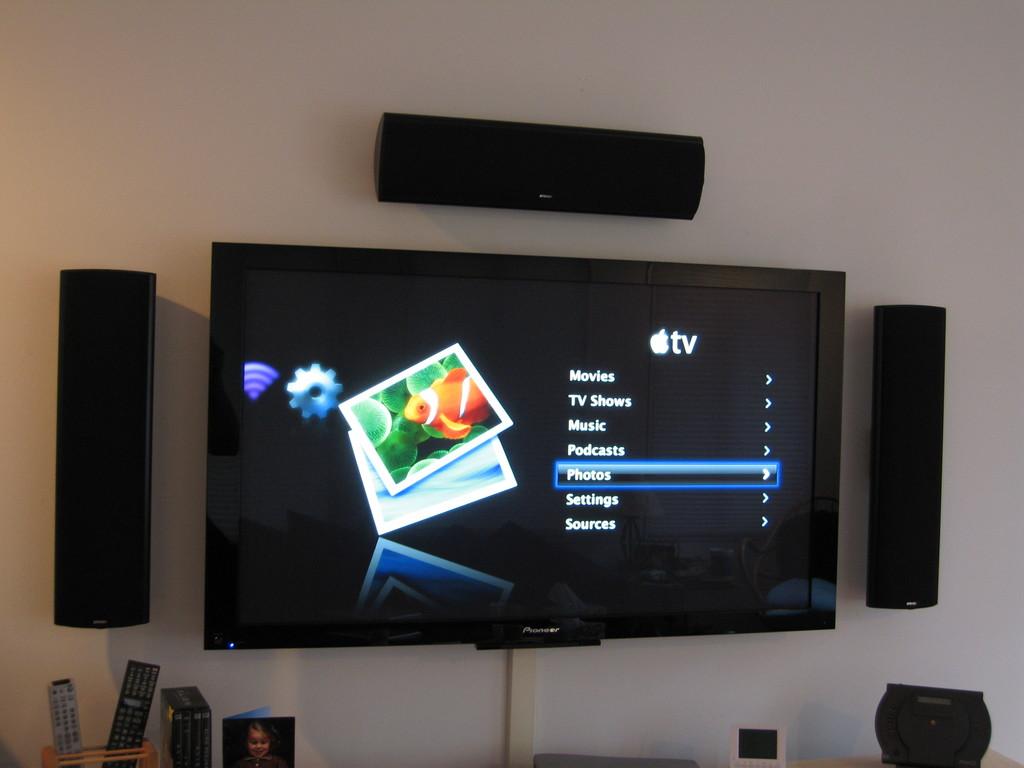What does the top line say on the tv?
Offer a terse response. Movies. What word is highlighted?
Your answer should be compact. Photos. 